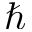<formula> <loc_0><loc_0><loc_500><loc_500>\hbar</formula> 